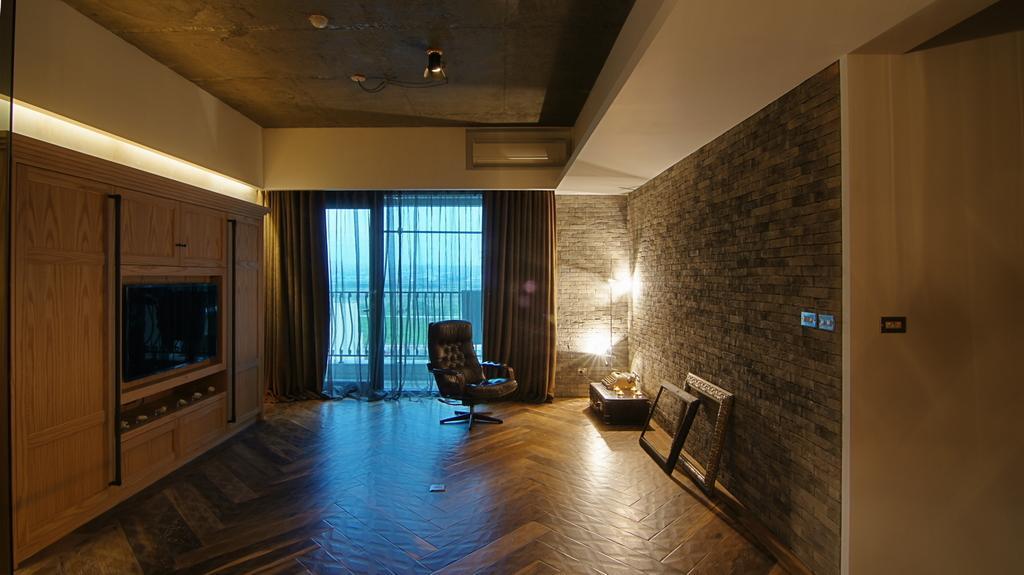In one or two sentences, can you explain what this image depicts? In the center of the image we can see a chair placed on the ground. To the right side of the image we can see two frames, an object placed on a table. To the left side, we can see a television on the wall and cupboards and some lights. In the background, we can see the curtains and metal railing. 